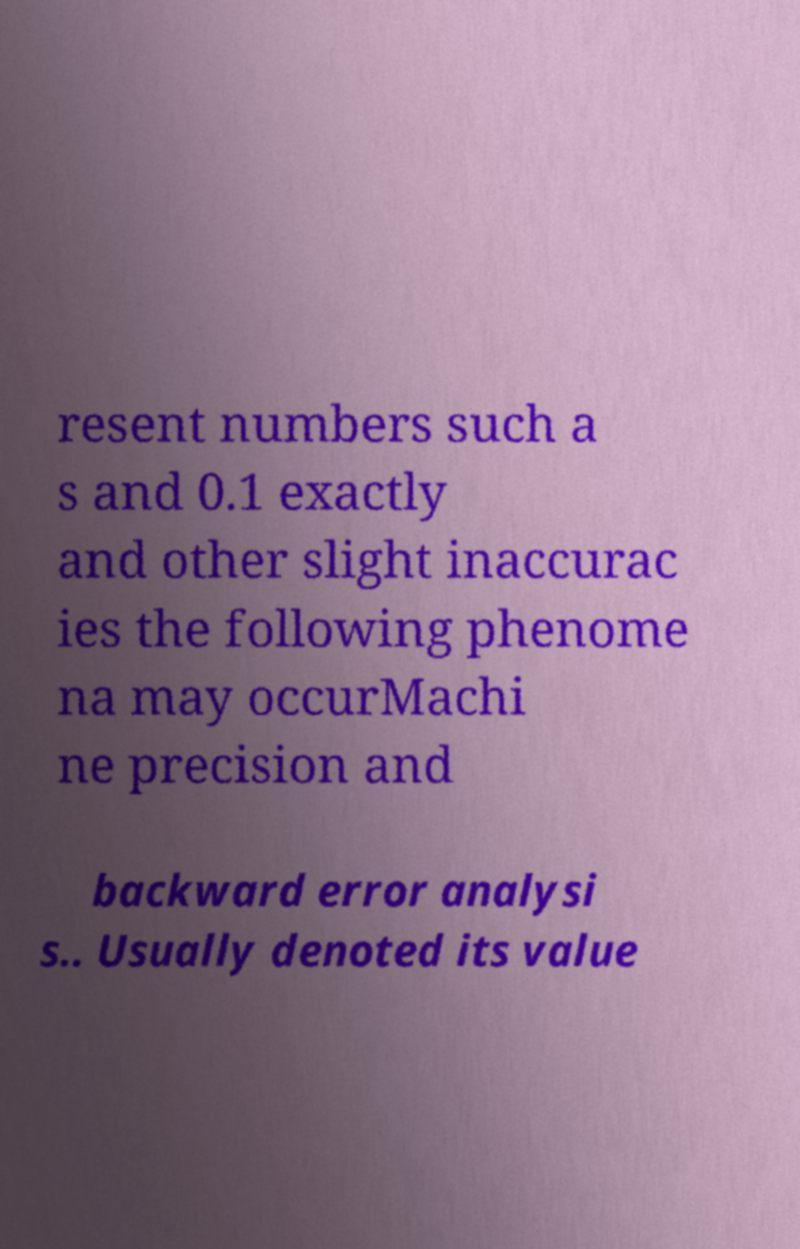Could you assist in decoding the text presented in this image and type it out clearly? resent numbers such a s and 0.1 exactly and other slight inaccurac ies the following phenome na may occurMachi ne precision and backward error analysi s.. Usually denoted its value 